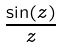<formula> <loc_0><loc_0><loc_500><loc_500>\frac { \sin ( z ) } { z }</formula> 